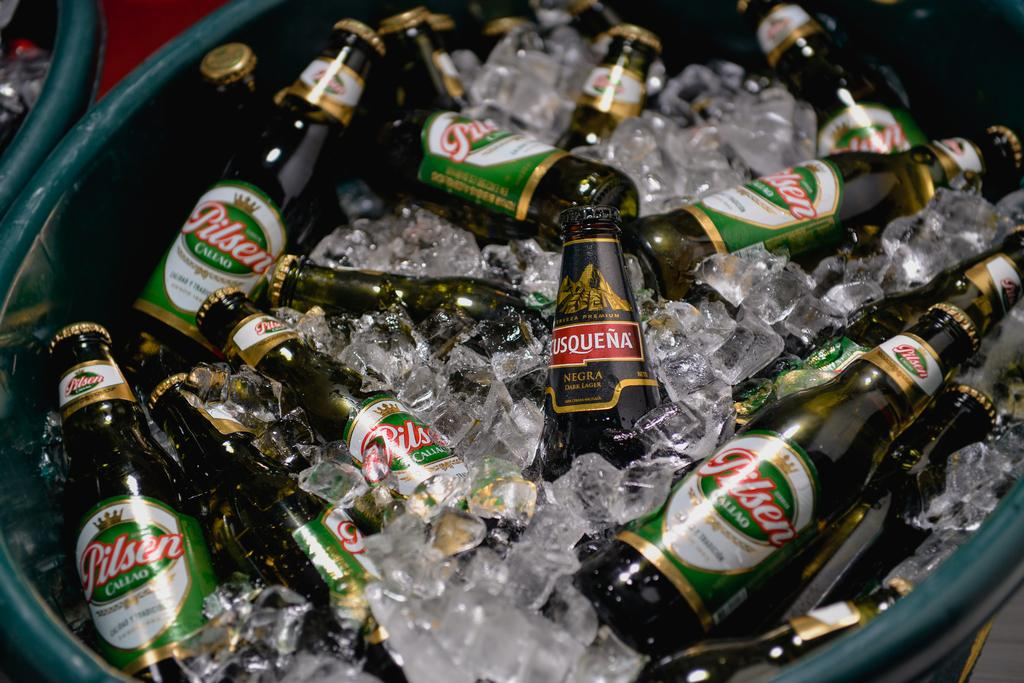<image>
Present a compact description of the photo's key features. Bucket of Pilsen beers covered in ice and water. 